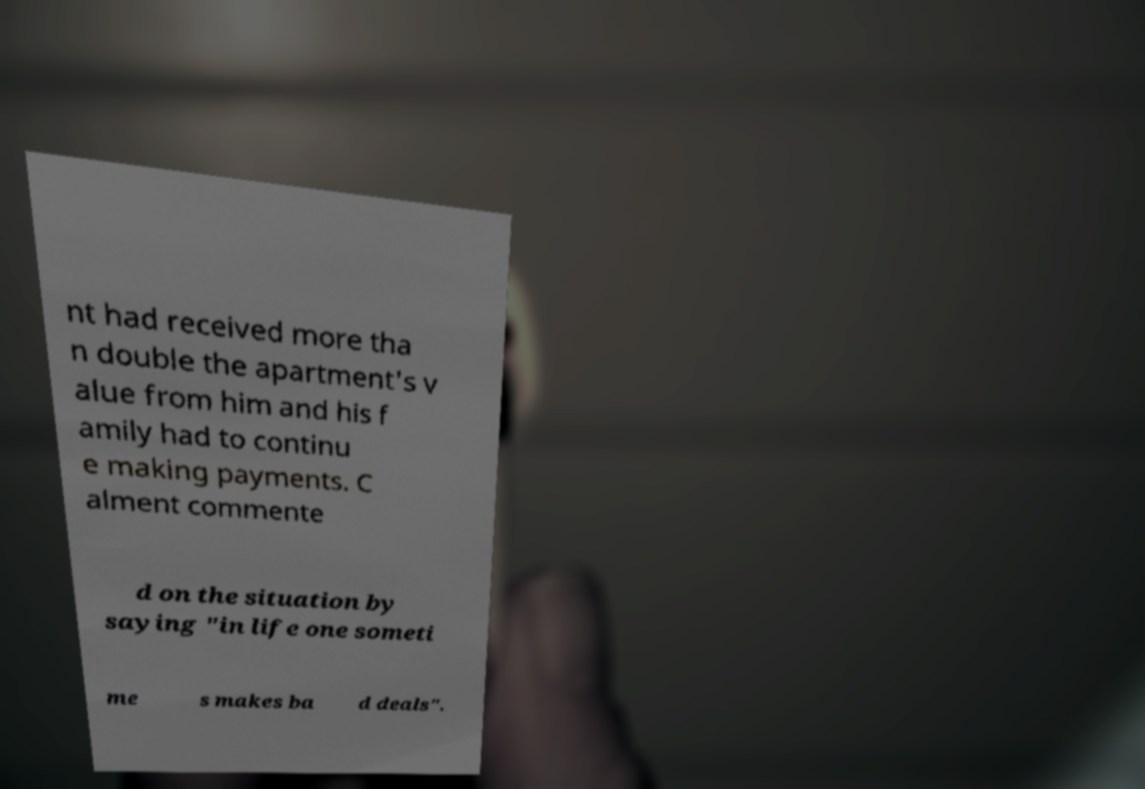Can you accurately transcribe the text from the provided image for me? nt had received more tha n double the apartment's v alue from him and his f amily had to continu e making payments. C alment commente d on the situation by saying "in life one someti me s makes ba d deals". 